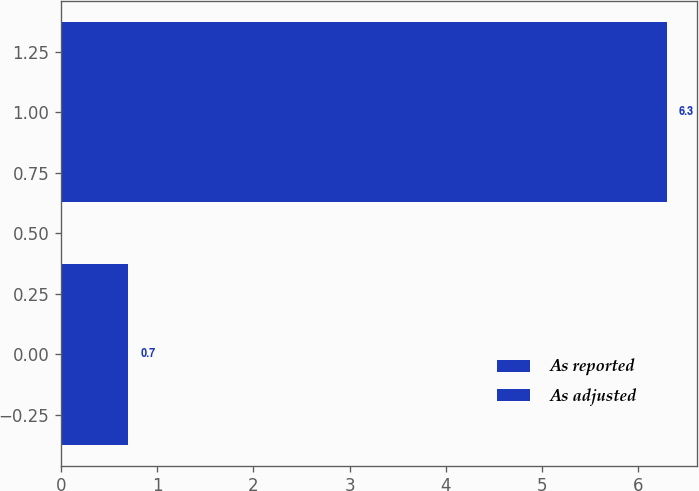Convert chart to OTSL. <chart><loc_0><loc_0><loc_500><loc_500><bar_chart><fcel>As reported<fcel>As adjusted<nl><fcel>0.7<fcel>6.3<nl></chart> 